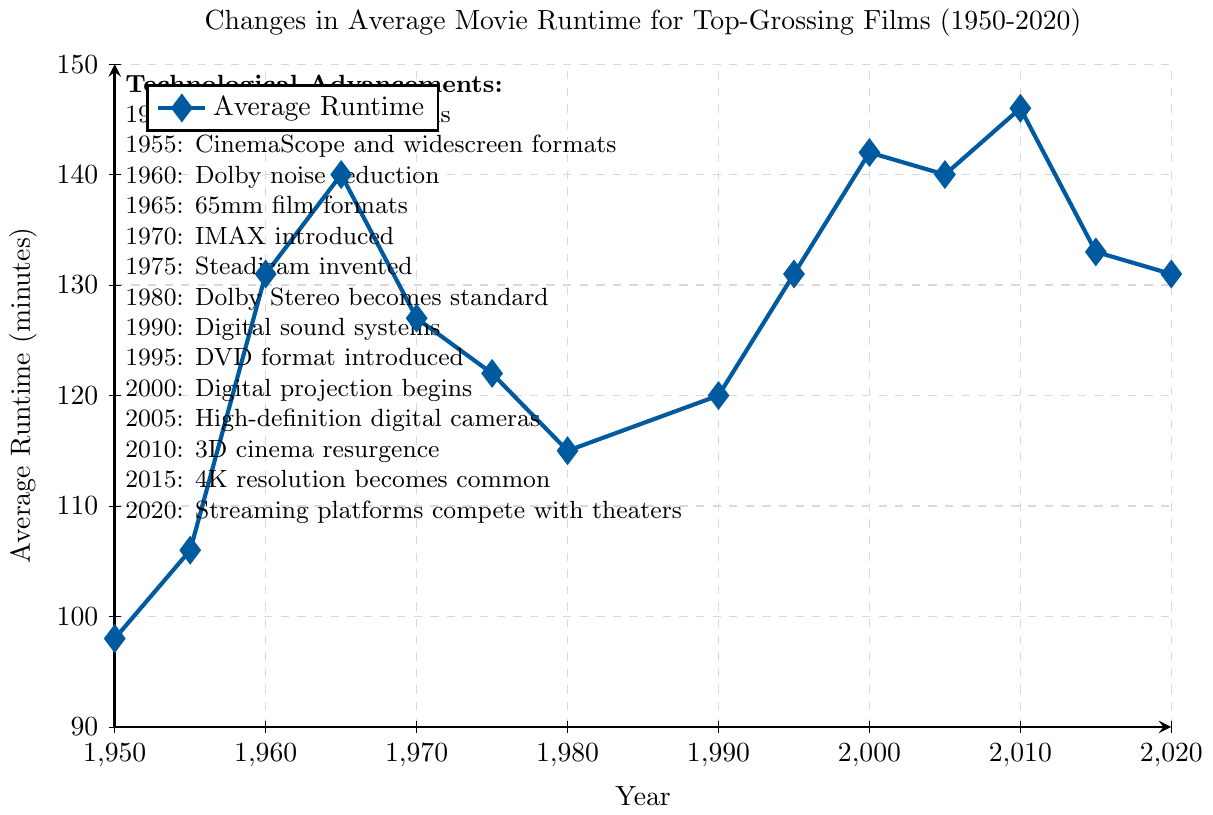What's the longest average runtime observed in the data? To find the longest average runtime, look at the y-axis for the highest value. The highest point on the plot corresponds to 2010 with 146 minutes.
Answer: 146 minutes In which year did the average runtime reach its peak value? To identify the year with the peak average runtime, find the highest point on the plot. The highest point is at the year 2010.
Answer: 2010 What is the average runtime difference between 1950 and 2010? To determine the average runtime difference, look at the runtimes for 1950 and 2010. The runtime in 1950 is 98 minutes and in 2010 it is 146 minutes. The difference is 146 - 98.
Answer: 48 minutes How does the runtime in 1975 compare to that in 1965? To compare, locate the runtimes for both years. In 1965, the runtime is 140 minutes, and in 1975 it is 122 minutes. 122 is less than 140.
Answer: 1975 has a shorter runtime Which technological advancement coincides with the shortest average runtime? Identify the shortest runtime on the plot, which is in 1950 with 98 minutes. The corresponding technological advancement is "Widespread color films."
Answer: Widespread color films Between 1955 and 1980, during which period does the average runtime consistently decrease? Examine the plot between 1955 and 1980 for periods of consistent decrease. After peaking at 140 minutes in 1965, the runtime consistently decreases until 1980.
Answer: 1965 to 1980 What is the average difference in runtime between the years 1950 and 2000? Look at the runtimes for 1950 and 2000. In 1950, the runtime is 98 minutes and in 2000 it is 142 minutes. The difference is 142 - 98.
Answer: 44 minutes Which year marks the transition from analog to digital sound systems, and how did the runtime change? Examine the year noted for digital sound systems. That year is 1990, with a runtime of 120 minutes. The closest previous year is 1980 with a runtime of 115 minutes, marking a 5-minute increase.
Answer: 1990, 5-minute increase How does the runtime in 2015 compare to that in 2010? Compare the runtimes for 2015 and 2010. In 2010, it is 146 minutes, and in 2015 it is 133 minutes, a decrease.
Answer: 2015 has a shorter runtime What is the technological advancement in 2005 and how did it impact the average runtime? Identify the advancement in 2005, which is High-definition digital cameras. The runtime in 2005 is 140 minutes, slightly lower than 2000's 142 minutes.
Answer: High-definition digital cameras, 2-minute decrease 